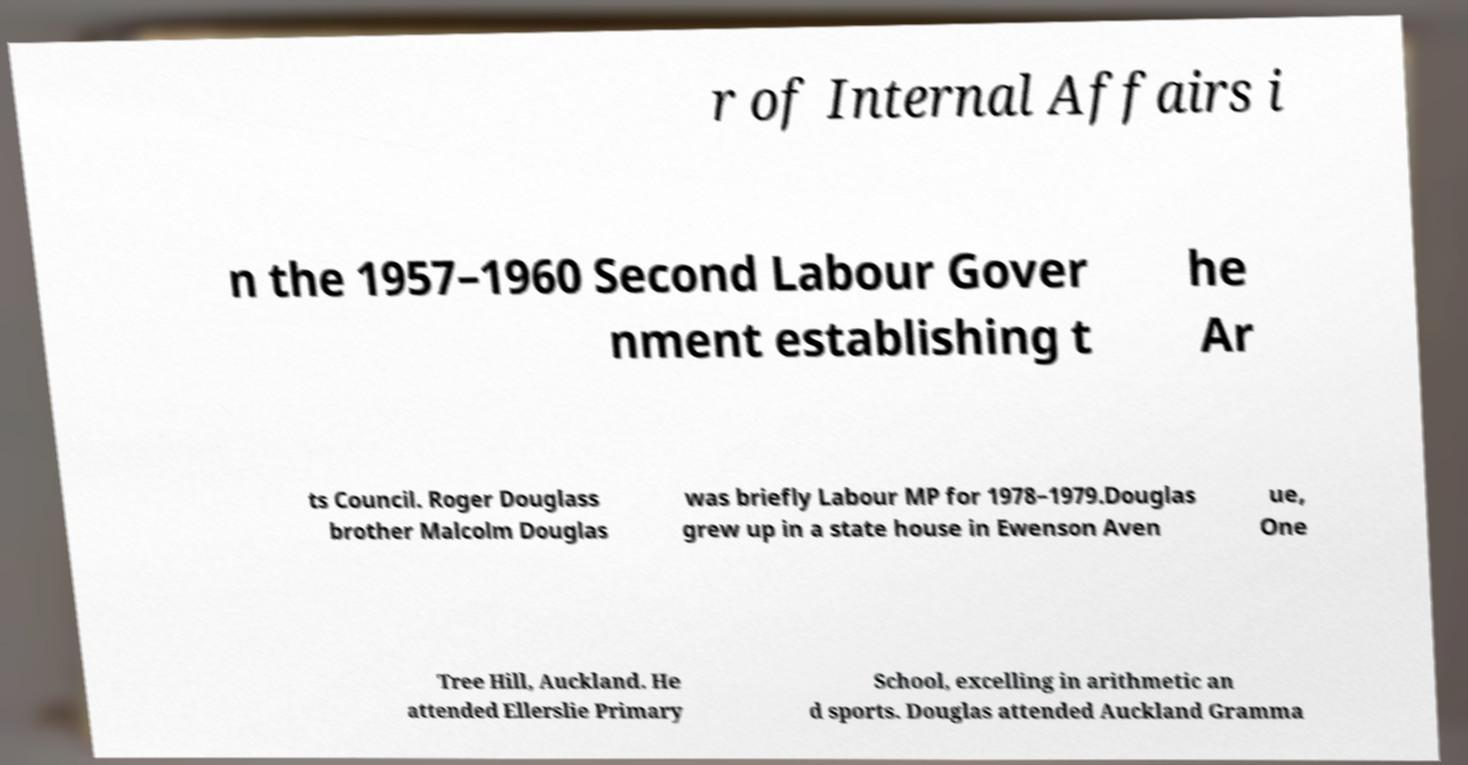I need the written content from this picture converted into text. Can you do that? r of Internal Affairs i n the 1957–1960 Second Labour Gover nment establishing t he Ar ts Council. Roger Douglass brother Malcolm Douglas was briefly Labour MP for 1978–1979.Douglas grew up in a state house in Ewenson Aven ue, One Tree Hill, Auckland. He attended Ellerslie Primary School, excelling in arithmetic an d sports. Douglas attended Auckland Gramma 